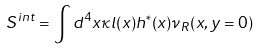<formula> <loc_0><loc_0><loc_500><loc_500>S ^ { i n t } = \int d ^ { 4 } x \kappa l ( x ) h ^ { * } ( x ) \nu _ { R } ( x , y = 0 )</formula> 